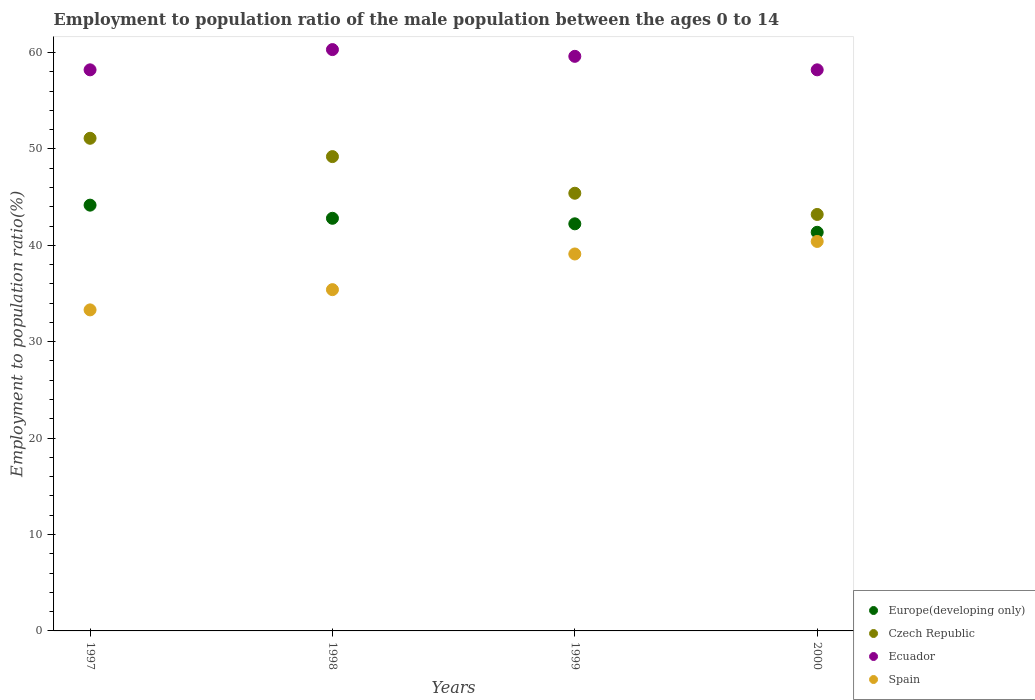What is the employment to population ratio in Europe(developing only) in 1999?
Provide a short and direct response. 42.23. Across all years, what is the maximum employment to population ratio in Europe(developing only)?
Offer a very short reply. 44.16. Across all years, what is the minimum employment to population ratio in Czech Republic?
Make the answer very short. 43.2. In which year was the employment to population ratio in Spain maximum?
Your answer should be compact. 2000. In which year was the employment to population ratio in Europe(developing only) minimum?
Give a very brief answer. 2000. What is the total employment to population ratio in Czech Republic in the graph?
Your answer should be compact. 188.9. What is the difference between the employment to population ratio in Europe(developing only) in 1998 and that in 2000?
Provide a succinct answer. 1.45. What is the difference between the employment to population ratio in Spain in 1998 and the employment to population ratio in Europe(developing only) in 1997?
Make the answer very short. -8.76. What is the average employment to population ratio in Czech Republic per year?
Your answer should be very brief. 47.23. In the year 1998, what is the difference between the employment to population ratio in Czech Republic and employment to population ratio in Europe(developing only)?
Your answer should be compact. 6.4. In how many years, is the employment to population ratio in Europe(developing only) greater than 28 %?
Give a very brief answer. 4. What is the ratio of the employment to population ratio in Czech Republic in 1997 to that in 1999?
Make the answer very short. 1.13. Is the difference between the employment to population ratio in Czech Republic in 1997 and 1999 greater than the difference between the employment to population ratio in Europe(developing only) in 1997 and 1999?
Keep it short and to the point. Yes. What is the difference between the highest and the second highest employment to population ratio in Ecuador?
Provide a short and direct response. 0.7. What is the difference between the highest and the lowest employment to population ratio in Europe(developing only)?
Your answer should be very brief. 2.82. Is the sum of the employment to population ratio in Czech Republic in 1998 and 2000 greater than the maximum employment to population ratio in Spain across all years?
Your answer should be very brief. Yes. Is it the case that in every year, the sum of the employment to population ratio in Czech Republic and employment to population ratio in Spain  is greater than the sum of employment to population ratio in Europe(developing only) and employment to population ratio in Ecuador?
Offer a terse response. No. Is it the case that in every year, the sum of the employment to population ratio in Spain and employment to population ratio in Ecuador  is greater than the employment to population ratio in Czech Republic?
Offer a terse response. Yes. Is the employment to population ratio in Spain strictly less than the employment to population ratio in Czech Republic over the years?
Your answer should be very brief. Yes. How many years are there in the graph?
Your answer should be very brief. 4. What is the difference between two consecutive major ticks on the Y-axis?
Provide a short and direct response. 10. Does the graph contain any zero values?
Provide a succinct answer. No. How many legend labels are there?
Ensure brevity in your answer.  4. How are the legend labels stacked?
Keep it short and to the point. Vertical. What is the title of the graph?
Your answer should be very brief. Employment to population ratio of the male population between the ages 0 to 14. Does "Liechtenstein" appear as one of the legend labels in the graph?
Give a very brief answer. No. What is the label or title of the X-axis?
Provide a succinct answer. Years. What is the Employment to population ratio(%) in Europe(developing only) in 1997?
Ensure brevity in your answer.  44.16. What is the Employment to population ratio(%) in Czech Republic in 1997?
Your answer should be compact. 51.1. What is the Employment to population ratio(%) in Ecuador in 1997?
Your answer should be very brief. 58.2. What is the Employment to population ratio(%) in Spain in 1997?
Provide a succinct answer. 33.3. What is the Employment to population ratio(%) of Europe(developing only) in 1998?
Offer a terse response. 42.8. What is the Employment to population ratio(%) in Czech Republic in 1998?
Provide a succinct answer. 49.2. What is the Employment to population ratio(%) in Ecuador in 1998?
Your answer should be very brief. 60.3. What is the Employment to population ratio(%) in Spain in 1998?
Ensure brevity in your answer.  35.4. What is the Employment to population ratio(%) of Europe(developing only) in 1999?
Your answer should be compact. 42.23. What is the Employment to population ratio(%) in Czech Republic in 1999?
Your answer should be compact. 45.4. What is the Employment to population ratio(%) of Ecuador in 1999?
Keep it short and to the point. 59.6. What is the Employment to population ratio(%) of Spain in 1999?
Provide a succinct answer. 39.1. What is the Employment to population ratio(%) of Europe(developing only) in 2000?
Your answer should be compact. 41.35. What is the Employment to population ratio(%) in Czech Republic in 2000?
Offer a terse response. 43.2. What is the Employment to population ratio(%) of Ecuador in 2000?
Give a very brief answer. 58.2. What is the Employment to population ratio(%) in Spain in 2000?
Your answer should be very brief. 40.4. Across all years, what is the maximum Employment to population ratio(%) in Europe(developing only)?
Offer a very short reply. 44.16. Across all years, what is the maximum Employment to population ratio(%) of Czech Republic?
Your response must be concise. 51.1. Across all years, what is the maximum Employment to population ratio(%) of Ecuador?
Give a very brief answer. 60.3. Across all years, what is the maximum Employment to population ratio(%) in Spain?
Offer a terse response. 40.4. Across all years, what is the minimum Employment to population ratio(%) of Europe(developing only)?
Your answer should be very brief. 41.35. Across all years, what is the minimum Employment to population ratio(%) of Czech Republic?
Make the answer very short. 43.2. Across all years, what is the minimum Employment to population ratio(%) in Ecuador?
Provide a short and direct response. 58.2. Across all years, what is the minimum Employment to population ratio(%) of Spain?
Offer a very short reply. 33.3. What is the total Employment to population ratio(%) of Europe(developing only) in the graph?
Offer a very short reply. 170.54. What is the total Employment to population ratio(%) of Czech Republic in the graph?
Ensure brevity in your answer.  188.9. What is the total Employment to population ratio(%) in Ecuador in the graph?
Ensure brevity in your answer.  236.3. What is the total Employment to population ratio(%) of Spain in the graph?
Provide a succinct answer. 148.2. What is the difference between the Employment to population ratio(%) of Europe(developing only) in 1997 and that in 1998?
Your answer should be very brief. 1.36. What is the difference between the Employment to population ratio(%) of Europe(developing only) in 1997 and that in 1999?
Your answer should be very brief. 1.94. What is the difference between the Employment to population ratio(%) in Ecuador in 1997 and that in 1999?
Make the answer very short. -1.4. What is the difference between the Employment to population ratio(%) in Europe(developing only) in 1997 and that in 2000?
Make the answer very short. 2.82. What is the difference between the Employment to population ratio(%) in Ecuador in 1997 and that in 2000?
Keep it short and to the point. 0. What is the difference between the Employment to population ratio(%) in Spain in 1997 and that in 2000?
Provide a short and direct response. -7.1. What is the difference between the Employment to population ratio(%) in Europe(developing only) in 1998 and that in 1999?
Give a very brief answer. 0.57. What is the difference between the Employment to population ratio(%) of Spain in 1998 and that in 1999?
Make the answer very short. -3.7. What is the difference between the Employment to population ratio(%) in Europe(developing only) in 1998 and that in 2000?
Your answer should be compact. 1.45. What is the difference between the Employment to population ratio(%) in Europe(developing only) in 1999 and that in 2000?
Offer a very short reply. 0.88. What is the difference between the Employment to population ratio(%) in Czech Republic in 1999 and that in 2000?
Your answer should be compact. 2.2. What is the difference between the Employment to population ratio(%) in Spain in 1999 and that in 2000?
Ensure brevity in your answer.  -1.3. What is the difference between the Employment to population ratio(%) in Europe(developing only) in 1997 and the Employment to population ratio(%) in Czech Republic in 1998?
Ensure brevity in your answer.  -5.04. What is the difference between the Employment to population ratio(%) in Europe(developing only) in 1997 and the Employment to population ratio(%) in Ecuador in 1998?
Your answer should be compact. -16.14. What is the difference between the Employment to population ratio(%) in Europe(developing only) in 1997 and the Employment to population ratio(%) in Spain in 1998?
Your answer should be very brief. 8.76. What is the difference between the Employment to population ratio(%) in Czech Republic in 1997 and the Employment to population ratio(%) in Spain in 1998?
Keep it short and to the point. 15.7. What is the difference between the Employment to population ratio(%) in Ecuador in 1997 and the Employment to population ratio(%) in Spain in 1998?
Your answer should be very brief. 22.8. What is the difference between the Employment to population ratio(%) in Europe(developing only) in 1997 and the Employment to population ratio(%) in Czech Republic in 1999?
Ensure brevity in your answer.  -1.24. What is the difference between the Employment to population ratio(%) of Europe(developing only) in 1997 and the Employment to population ratio(%) of Ecuador in 1999?
Ensure brevity in your answer.  -15.44. What is the difference between the Employment to population ratio(%) of Europe(developing only) in 1997 and the Employment to population ratio(%) of Spain in 1999?
Your answer should be very brief. 5.06. What is the difference between the Employment to population ratio(%) of Czech Republic in 1997 and the Employment to population ratio(%) of Spain in 1999?
Provide a succinct answer. 12. What is the difference between the Employment to population ratio(%) of Ecuador in 1997 and the Employment to population ratio(%) of Spain in 1999?
Provide a succinct answer. 19.1. What is the difference between the Employment to population ratio(%) of Europe(developing only) in 1997 and the Employment to population ratio(%) of Czech Republic in 2000?
Ensure brevity in your answer.  0.96. What is the difference between the Employment to population ratio(%) in Europe(developing only) in 1997 and the Employment to population ratio(%) in Ecuador in 2000?
Provide a succinct answer. -14.04. What is the difference between the Employment to population ratio(%) of Europe(developing only) in 1997 and the Employment to population ratio(%) of Spain in 2000?
Provide a succinct answer. 3.76. What is the difference between the Employment to population ratio(%) in Czech Republic in 1997 and the Employment to population ratio(%) in Ecuador in 2000?
Your response must be concise. -7.1. What is the difference between the Employment to population ratio(%) of Europe(developing only) in 1998 and the Employment to population ratio(%) of Czech Republic in 1999?
Provide a short and direct response. -2.6. What is the difference between the Employment to population ratio(%) in Europe(developing only) in 1998 and the Employment to population ratio(%) in Ecuador in 1999?
Your answer should be very brief. -16.8. What is the difference between the Employment to population ratio(%) in Europe(developing only) in 1998 and the Employment to population ratio(%) in Spain in 1999?
Your response must be concise. 3.7. What is the difference between the Employment to population ratio(%) in Ecuador in 1998 and the Employment to population ratio(%) in Spain in 1999?
Give a very brief answer. 21.2. What is the difference between the Employment to population ratio(%) in Europe(developing only) in 1998 and the Employment to population ratio(%) in Czech Republic in 2000?
Ensure brevity in your answer.  -0.4. What is the difference between the Employment to population ratio(%) of Europe(developing only) in 1998 and the Employment to population ratio(%) of Ecuador in 2000?
Offer a very short reply. -15.4. What is the difference between the Employment to population ratio(%) of Europe(developing only) in 1998 and the Employment to population ratio(%) of Spain in 2000?
Ensure brevity in your answer.  2.4. What is the difference between the Employment to population ratio(%) in Czech Republic in 1998 and the Employment to population ratio(%) in Spain in 2000?
Give a very brief answer. 8.8. What is the difference between the Employment to population ratio(%) in Europe(developing only) in 1999 and the Employment to population ratio(%) in Czech Republic in 2000?
Offer a terse response. -0.97. What is the difference between the Employment to population ratio(%) in Europe(developing only) in 1999 and the Employment to population ratio(%) in Ecuador in 2000?
Your answer should be very brief. -15.97. What is the difference between the Employment to population ratio(%) in Europe(developing only) in 1999 and the Employment to population ratio(%) in Spain in 2000?
Provide a short and direct response. 1.83. What is the average Employment to population ratio(%) in Europe(developing only) per year?
Your response must be concise. 42.64. What is the average Employment to population ratio(%) of Czech Republic per year?
Ensure brevity in your answer.  47.23. What is the average Employment to population ratio(%) of Ecuador per year?
Offer a very short reply. 59.08. What is the average Employment to population ratio(%) in Spain per year?
Provide a short and direct response. 37.05. In the year 1997, what is the difference between the Employment to population ratio(%) of Europe(developing only) and Employment to population ratio(%) of Czech Republic?
Offer a very short reply. -6.94. In the year 1997, what is the difference between the Employment to population ratio(%) in Europe(developing only) and Employment to population ratio(%) in Ecuador?
Offer a very short reply. -14.04. In the year 1997, what is the difference between the Employment to population ratio(%) in Europe(developing only) and Employment to population ratio(%) in Spain?
Keep it short and to the point. 10.86. In the year 1997, what is the difference between the Employment to population ratio(%) of Czech Republic and Employment to population ratio(%) of Ecuador?
Keep it short and to the point. -7.1. In the year 1997, what is the difference between the Employment to population ratio(%) in Czech Republic and Employment to population ratio(%) in Spain?
Your response must be concise. 17.8. In the year 1997, what is the difference between the Employment to population ratio(%) in Ecuador and Employment to population ratio(%) in Spain?
Ensure brevity in your answer.  24.9. In the year 1998, what is the difference between the Employment to population ratio(%) in Europe(developing only) and Employment to population ratio(%) in Czech Republic?
Your answer should be compact. -6.4. In the year 1998, what is the difference between the Employment to population ratio(%) of Europe(developing only) and Employment to population ratio(%) of Ecuador?
Your answer should be very brief. -17.5. In the year 1998, what is the difference between the Employment to population ratio(%) of Europe(developing only) and Employment to population ratio(%) of Spain?
Ensure brevity in your answer.  7.4. In the year 1998, what is the difference between the Employment to population ratio(%) of Czech Republic and Employment to population ratio(%) of Ecuador?
Offer a very short reply. -11.1. In the year 1998, what is the difference between the Employment to population ratio(%) of Czech Republic and Employment to population ratio(%) of Spain?
Provide a succinct answer. 13.8. In the year 1998, what is the difference between the Employment to population ratio(%) of Ecuador and Employment to population ratio(%) of Spain?
Your response must be concise. 24.9. In the year 1999, what is the difference between the Employment to population ratio(%) of Europe(developing only) and Employment to population ratio(%) of Czech Republic?
Your answer should be very brief. -3.17. In the year 1999, what is the difference between the Employment to population ratio(%) in Europe(developing only) and Employment to population ratio(%) in Ecuador?
Your answer should be very brief. -17.37. In the year 1999, what is the difference between the Employment to population ratio(%) of Europe(developing only) and Employment to population ratio(%) of Spain?
Give a very brief answer. 3.13. In the year 1999, what is the difference between the Employment to population ratio(%) of Czech Republic and Employment to population ratio(%) of Ecuador?
Ensure brevity in your answer.  -14.2. In the year 1999, what is the difference between the Employment to population ratio(%) in Czech Republic and Employment to population ratio(%) in Spain?
Give a very brief answer. 6.3. In the year 2000, what is the difference between the Employment to population ratio(%) in Europe(developing only) and Employment to population ratio(%) in Czech Republic?
Keep it short and to the point. -1.85. In the year 2000, what is the difference between the Employment to population ratio(%) in Europe(developing only) and Employment to population ratio(%) in Ecuador?
Offer a very short reply. -16.85. In the year 2000, what is the difference between the Employment to population ratio(%) of Europe(developing only) and Employment to population ratio(%) of Spain?
Make the answer very short. 0.95. In the year 2000, what is the difference between the Employment to population ratio(%) of Czech Republic and Employment to population ratio(%) of Ecuador?
Provide a short and direct response. -15. What is the ratio of the Employment to population ratio(%) of Europe(developing only) in 1997 to that in 1998?
Provide a succinct answer. 1.03. What is the ratio of the Employment to population ratio(%) in Czech Republic in 1997 to that in 1998?
Give a very brief answer. 1.04. What is the ratio of the Employment to population ratio(%) of Ecuador in 1997 to that in 1998?
Give a very brief answer. 0.97. What is the ratio of the Employment to population ratio(%) in Spain in 1997 to that in 1998?
Offer a very short reply. 0.94. What is the ratio of the Employment to population ratio(%) of Europe(developing only) in 1997 to that in 1999?
Offer a terse response. 1.05. What is the ratio of the Employment to population ratio(%) of Czech Republic in 1997 to that in 1999?
Keep it short and to the point. 1.13. What is the ratio of the Employment to population ratio(%) of Ecuador in 1997 to that in 1999?
Ensure brevity in your answer.  0.98. What is the ratio of the Employment to population ratio(%) in Spain in 1997 to that in 1999?
Ensure brevity in your answer.  0.85. What is the ratio of the Employment to population ratio(%) of Europe(developing only) in 1997 to that in 2000?
Ensure brevity in your answer.  1.07. What is the ratio of the Employment to population ratio(%) of Czech Republic in 1997 to that in 2000?
Your answer should be compact. 1.18. What is the ratio of the Employment to population ratio(%) of Ecuador in 1997 to that in 2000?
Offer a very short reply. 1. What is the ratio of the Employment to population ratio(%) in Spain in 1997 to that in 2000?
Your answer should be very brief. 0.82. What is the ratio of the Employment to population ratio(%) in Europe(developing only) in 1998 to that in 1999?
Offer a terse response. 1.01. What is the ratio of the Employment to population ratio(%) of Czech Republic in 1998 to that in 1999?
Give a very brief answer. 1.08. What is the ratio of the Employment to population ratio(%) in Ecuador in 1998 to that in 1999?
Your answer should be compact. 1.01. What is the ratio of the Employment to population ratio(%) of Spain in 1998 to that in 1999?
Provide a short and direct response. 0.91. What is the ratio of the Employment to population ratio(%) of Europe(developing only) in 1998 to that in 2000?
Offer a very short reply. 1.04. What is the ratio of the Employment to population ratio(%) in Czech Republic in 1998 to that in 2000?
Provide a succinct answer. 1.14. What is the ratio of the Employment to population ratio(%) of Ecuador in 1998 to that in 2000?
Ensure brevity in your answer.  1.04. What is the ratio of the Employment to population ratio(%) of Spain in 1998 to that in 2000?
Make the answer very short. 0.88. What is the ratio of the Employment to population ratio(%) in Europe(developing only) in 1999 to that in 2000?
Make the answer very short. 1.02. What is the ratio of the Employment to population ratio(%) in Czech Republic in 1999 to that in 2000?
Keep it short and to the point. 1.05. What is the ratio of the Employment to population ratio(%) in Ecuador in 1999 to that in 2000?
Provide a short and direct response. 1.02. What is the ratio of the Employment to population ratio(%) in Spain in 1999 to that in 2000?
Give a very brief answer. 0.97. What is the difference between the highest and the second highest Employment to population ratio(%) in Europe(developing only)?
Make the answer very short. 1.36. What is the difference between the highest and the second highest Employment to population ratio(%) in Czech Republic?
Your response must be concise. 1.9. What is the difference between the highest and the second highest Employment to population ratio(%) in Spain?
Your answer should be very brief. 1.3. What is the difference between the highest and the lowest Employment to population ratio(%) in Europe(developing only)?
Give a very brief answer. 2.82. What is the difference between the highest and the lowest Employment to population ratio(%) in Ecuador?
Keep it short and to the point. 2.1. 